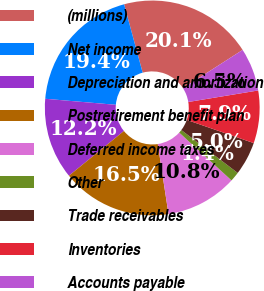Convert chart. <chart><loc_0><loc_0><loc_500><loc_500><pie_chart><fcel>(millions)<fcel>Net income<fcel>Depreciation and amortization<fcel>Postretirement benefit plan<fcel>Deferred income taxes<fcel>Other<fcel>Trade receivables<fcel>Inventories<fcel>Accounts payable<nl><fcel>20.14%<fcel>19.42%<fcel>12.23%<fcel>16.55%<fcel>10.79%<fcel>1.44%<fcel>5.04%<fcel>7.91%<fcel>6.48%<nl></chart> 